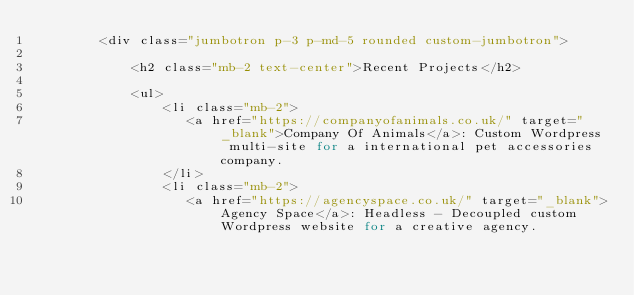<code> <loc_0><loc_0><loc_500><loc_500><_PHP_>        <div class="jumbotron p-3 p-md-5 rounded custom-jumbotron">

            <h2 class="mb-2 text-center">Recent Projects</h2>

            <ul>
                <li class="mb-2">
                   <a href="https://companyofanimals.co.uk/" target="_blank">Company Of Animals</a>: Custom Wordpress multi-site for a international pet accessories company.
                </li>
                <li class="mb-2">
                   <a href="https://agencyspace.co.uk/" target="_blank">Agency Space</a>: Headless - Decoupled custom Wordpress website for a creative agency.</code> 